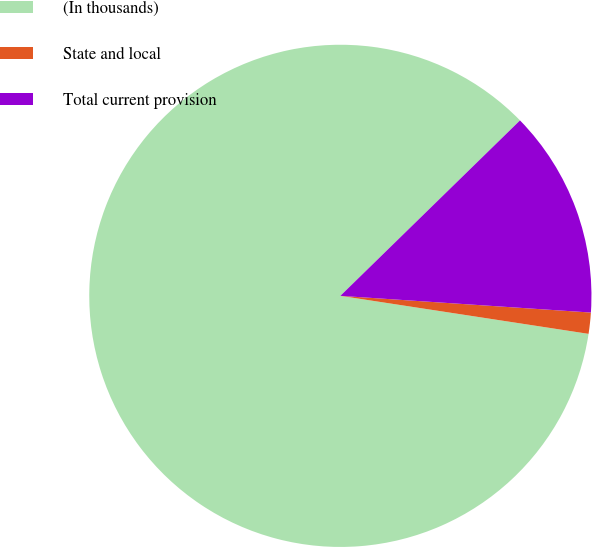Convert chart. <chart><loc_0><loc_0><loc_500><loc_500><pie_chart><fcel>(In thousands)<fcel>State and local<fcel>Total current provision<nl><fcel>85.27%<fcel>1.36%<fcel>13.37%<nl></chart> 